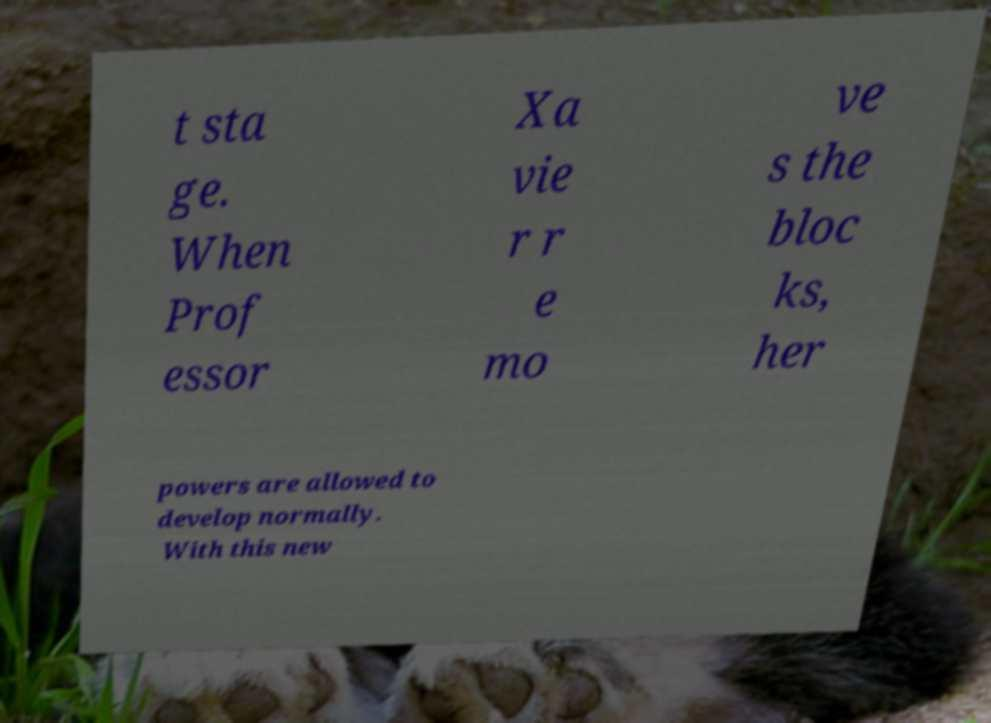Can you read and provide the text displayed in the image?This photo seems to have some interesting text. Can you extract and type it out for me? t sta ge. When Prof essor Xa vie r r e mo ve s the bloc ks, her powers are allowed to develop normally. With this new 